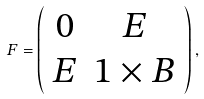<formula> <loc_0><loc_0><loc_500><loc_500>F = \left ( \begin{array} { c c } 0 & { E } \\ { E } & { 1 } \times { B } \end{array} \right ) ,</formula> 